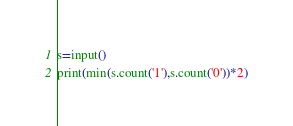<code> <loc_0><loc_0><loc_500><loc_500><_Python_>s=input()
print(min(s.count('1'),s.count('0'))*2)</code> 